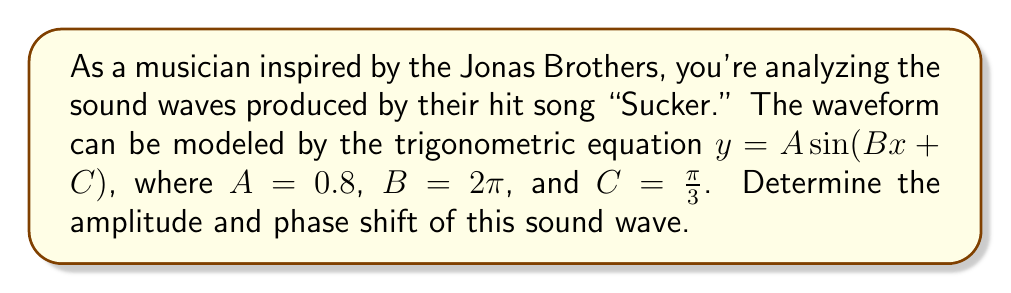What is the answer to this math problem? Let's break this down step-by-step:

1) The general form of a sine wave is:

   $y = A \sin(Bx + C)$

   Where:
   - $A$ is the amplitude
   - $B$ is the angular frequency
   - $C$ is the phase shift

2) In this case, we're given:
   $A = 0.8$
   $B = 2\pi$
   $C = \frac{\pi}{3}$

3) Amplitude:
   The amplitude is directly given by the coefficient $A$. Therefore, the amplitude is 0.8.

4) Phase shift:
   To find the phase shift, we need to manipulate the equation into the form:
   
   $y = A \sin(B(x - D))$

   Where $D$ is the phase shift.

5) We have $Bx + C$, which can be rewritten as:

   $B(x + \frac{C}{B})$

6) Substituting the values:

   $2\pi(x + \frac{\pi/3}{2\pi}) = 2\pi(x + \frac{1}{6})$

7) Therefore, the phase shift $D = -\frac{1}{6}$

   Note: The negative sign indicates a shift to the left.
Answer: Amplitude: 0.8, Phase shift: $-\frac{1}{6}$ 